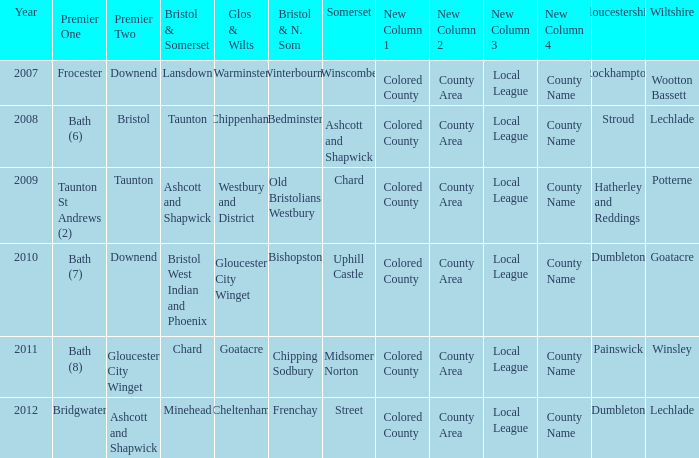What is the glos & wilts where the bristol & somerset is lansdown? Warminster. 